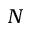<formula> <loc_0><loc_0><loc_500><loc_500>N</formula> 